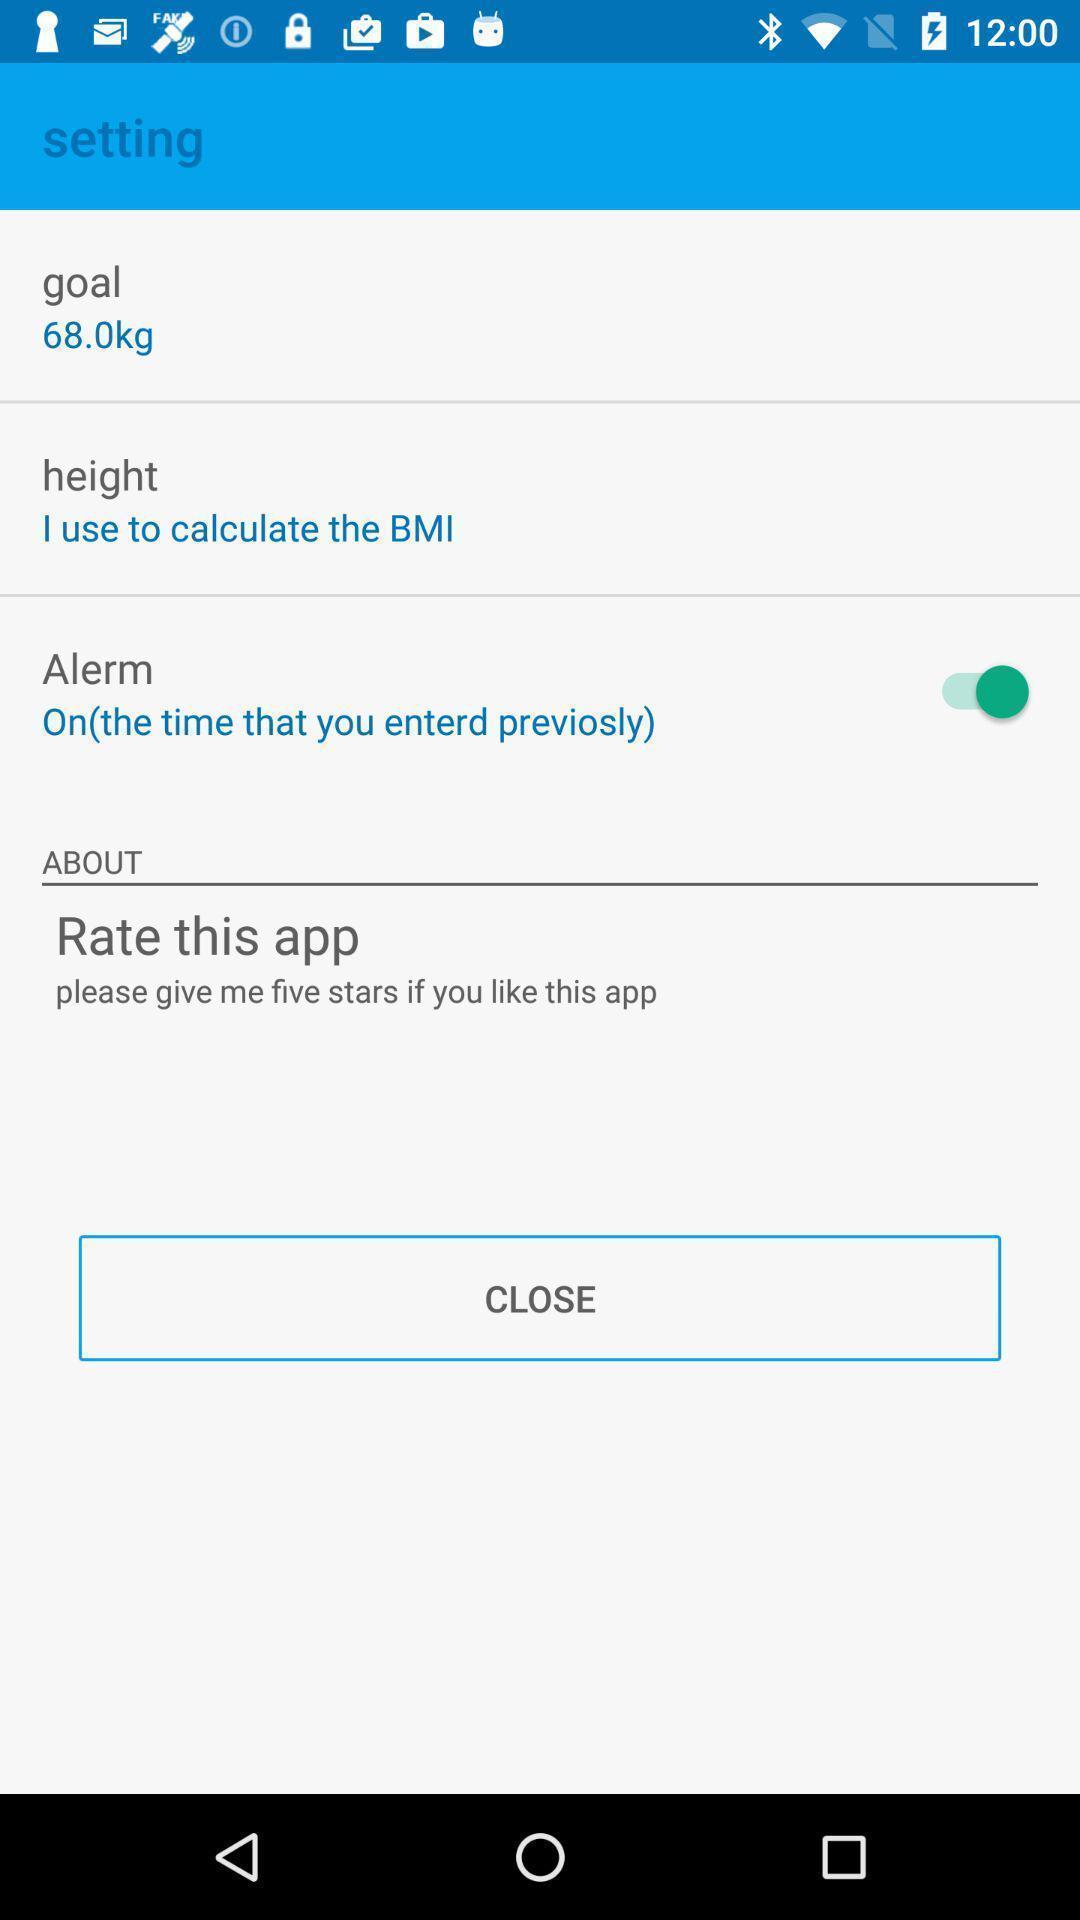Provide a detailed account of this screenshot. Settings page displaying of an fitness application. 